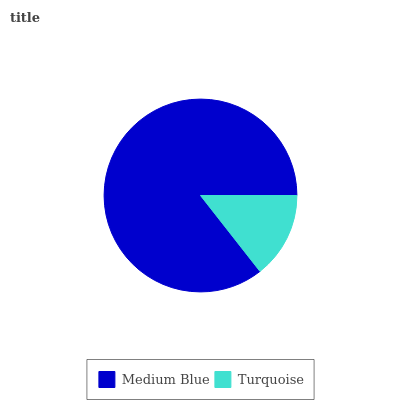Is Turquoise the minimum?
Answer yes or no. Yes. Is Medium Blue the maximum?
Answer yes or no. Yes. Is Turquoise the maximum?
Answer yes or no. No. Is Medium Blue greater than Turquoise?
Answer yes or no. Yes. Is Turquoise less than Medium Blue?
Answer yes or no. Yes. Is Turquoise greater than Medium Blue?
Answer yes or no. No. Is Medium Blue less than Turquoise?
Answer yes or no. No. Is Medium Blue the high median?
Answer yes or no. Yes. Is Turquoise the low median?
Answer yes or no. Yes. Is Turquoise the high median?
Answer yes or no. No. Is Medium Blue the low median?
Answer yes or no. No. 